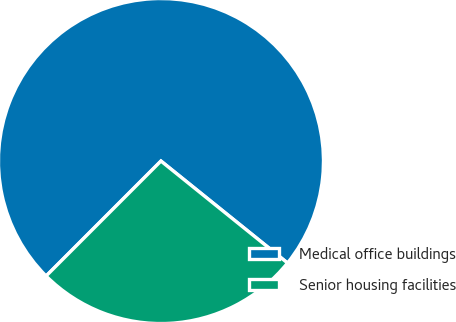Convert chart to OTSL. <chart><loc_0><loc_0><loc_500><loc_500><pie_chart><fcel>Medical office buildings<fcel>Senior housing facilities<nl><fcel>73.3%<fcel>26.7%<nl></chart> 